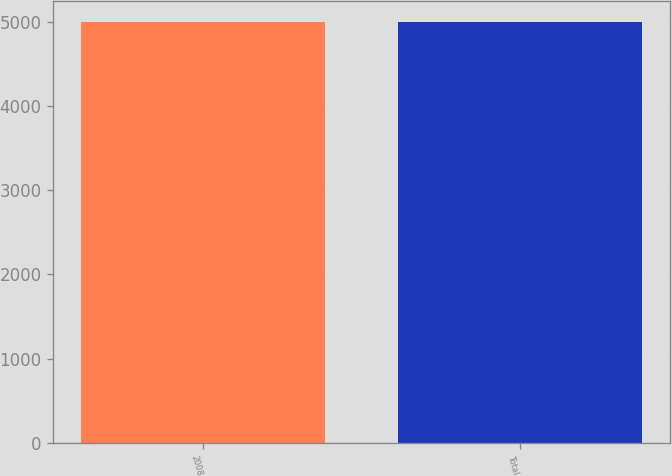<chart> <loc_0><loc_0><loc_500><loc_500><bar_chart><fcel>2008<fcel>Total<nl><fcel>4998<fcel>4998.1<nl></chart> 